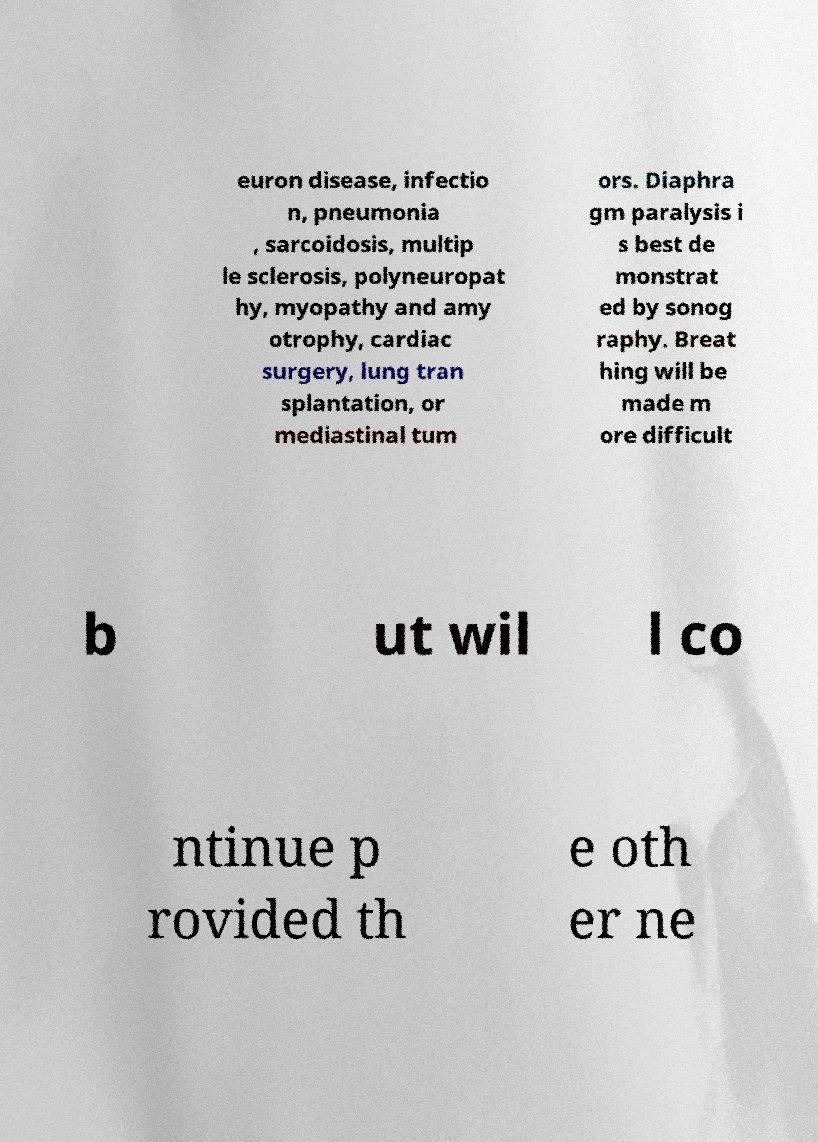There's text embedded in this image that I need extracted. Can you transcribe it verbatim? euron disease, infectio n, pneumonia , sarcoidosis, multip le sclerosis, polyneuropat hy, myopathy and amy otrophy, cardiac surgery, lung tran splantation, or mediastinal tum ors. Diaphra gm paralysis i s best de monstrat ed by sonog raphy. Breat hing will be made m ore difficult b ut wil l co ntinue p rovided th e oth er ne 